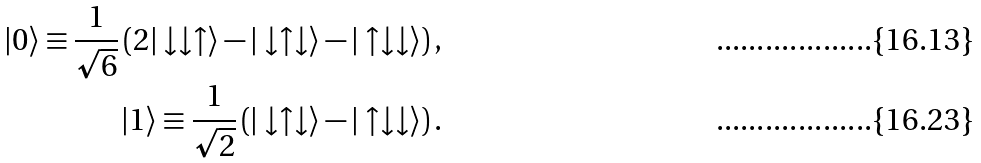<formula> <loc_0><loc_0><loc_500><loc_500>| 0 \rangle \equiv \frac { 1 } { \sqrt { 6 } } \left ( 2 | \downarrow \downarrow \uparrow \rangle - | \downarrow \uparrow \downarrow \rangle - | \uparrow \downarrow \downarrow \rangle \right ) , \\ | 1 \rangle \equiv \frac { 1 } { \sqrt { 2 } } \left ( | \downarrow \uparrow \downarrow \rangle - | \uparrow \downarrow \downarrow \rangle \right ) .</formula> 